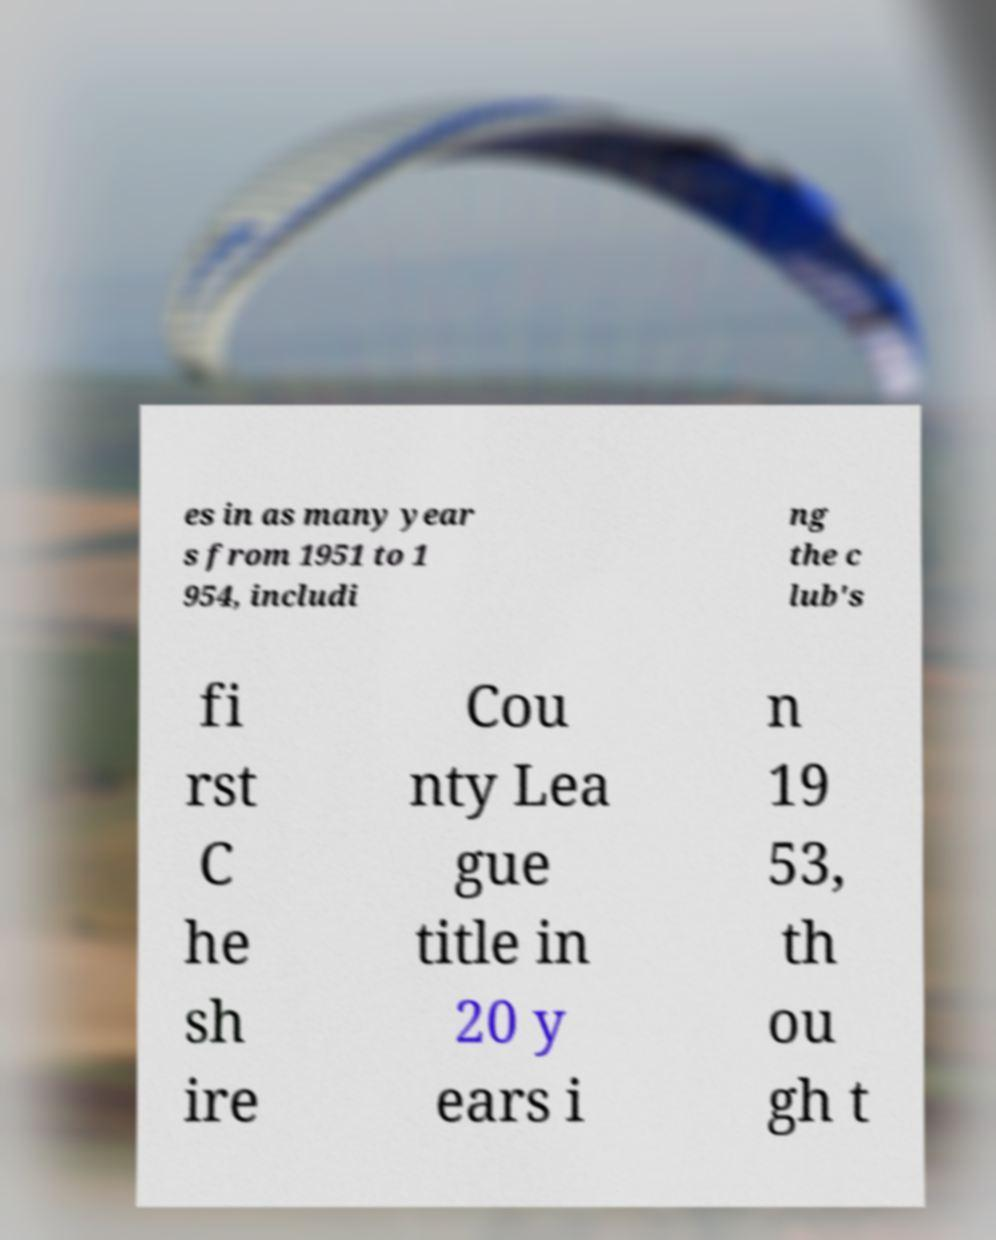Could you assist in decoding the text presented in this image and type it out clearly? es in as many year s from 1951 to 1 954, includi ng the c lub's fi rst C he sh ire Cou nty Lea gue title in 20 y ears i n 19 53, th ou gh t 